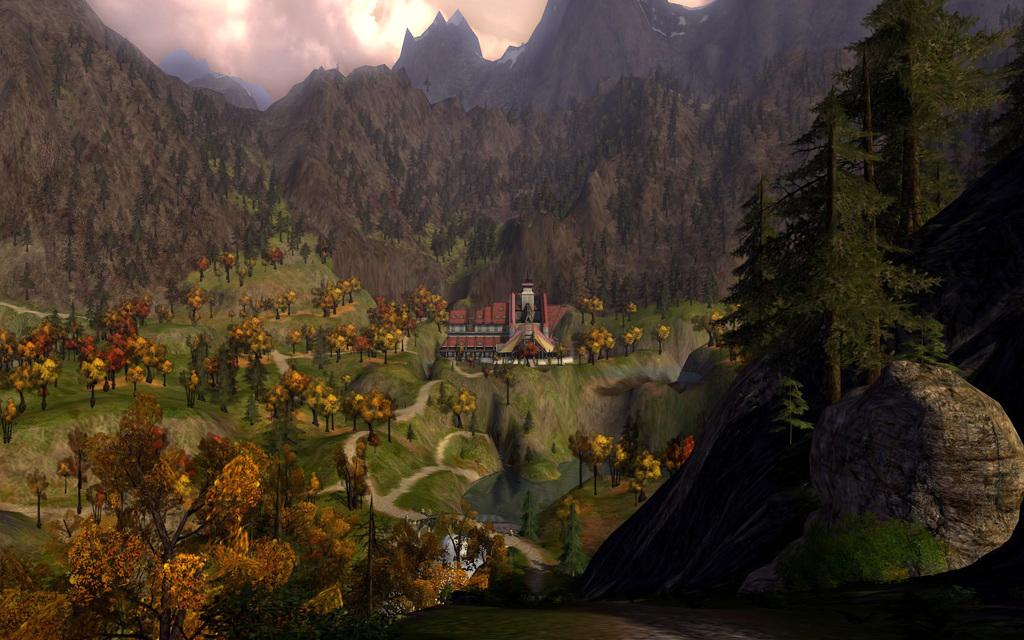What type of vegetation can be seen in the image? There are trees in the image. What is the ground cover in the image? The grass is visible in the image. What type of geological features are present in the image? Rocks are present in the image. What type of large landforms can be seen in the image? Mountains are in the image. What is visible in the background of the image? The sky is visible in the background of the image. Can you tell me the grade of the cattle in the image? There are no cattle present in the image, so it is not possible to determine their grade. 